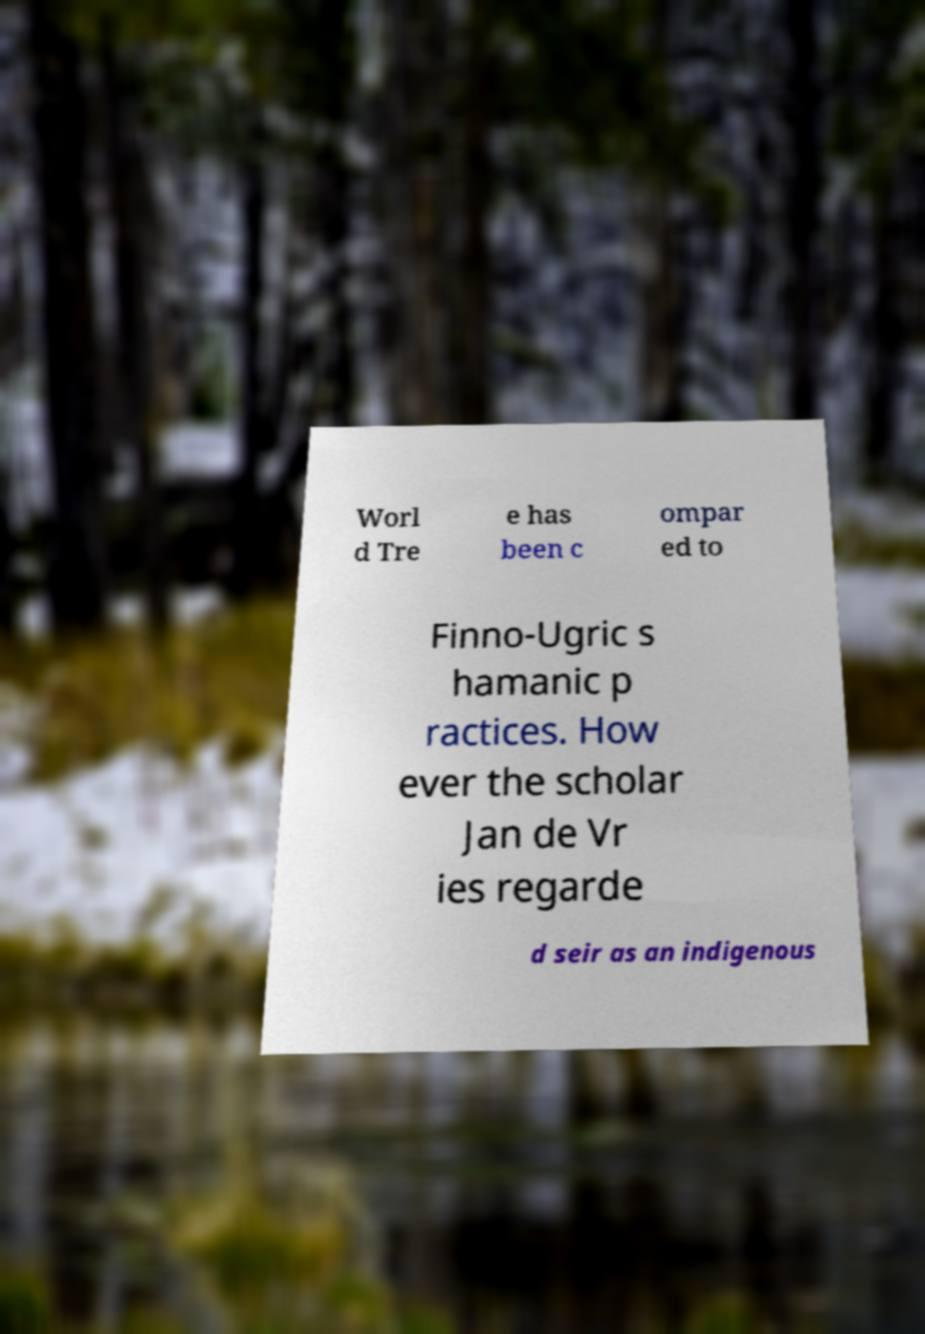There's text embedded in this image that I need extracted. Can you transcribe it verbatim? Worl d Tre e has been c ompar ed to Finno-Ugric s hamanic p ractices. How ever the scholar Jan de Vr ies regarde d seir as an indigenous 